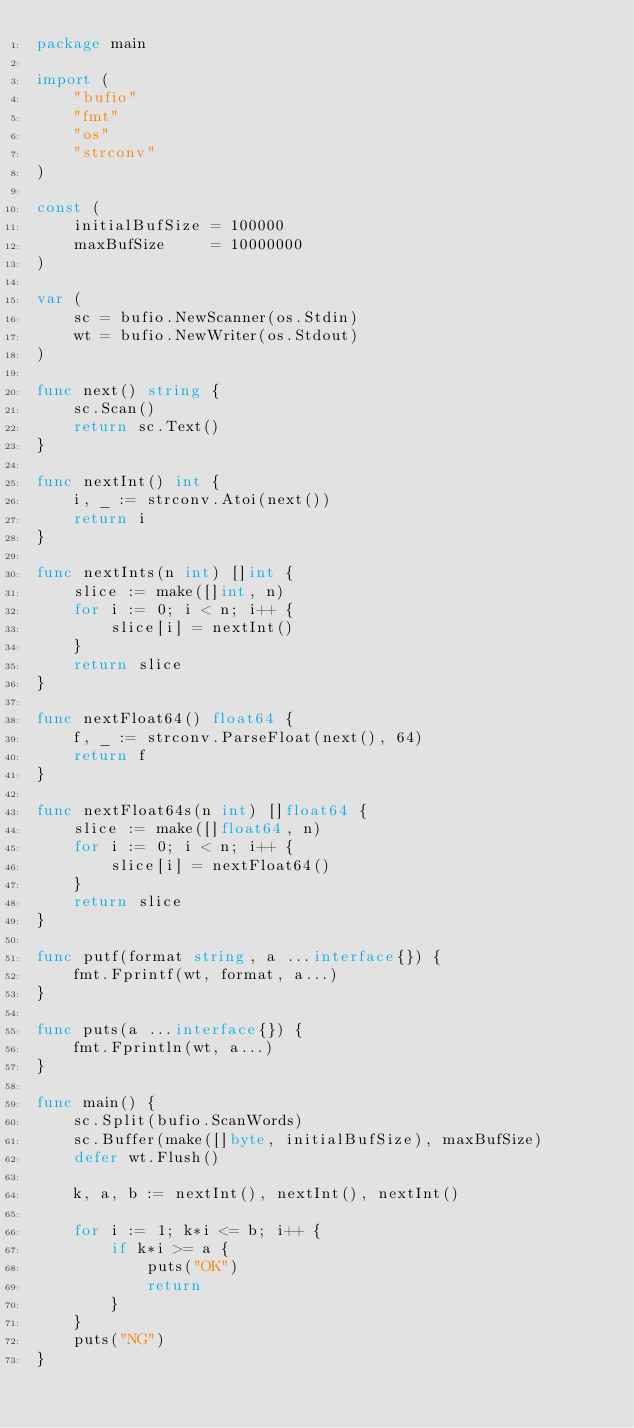<code> <loc_0><loc_0><loc_500><loc_500><_Go_>package main

import (
	"bufio"
	"fmt"
	"os"
	"strconv"
)

const (
	initialBufSize = 100000
	maxBufSize     = 10000000
)

var (
	sc = bufio.NewScanner(os.Stdin)
	wt = bufio.NewWriter(os.Stdout)
)

func next() string {
	sc.Scan()
	return sc.Text()
}

func nextInt() int {
	i, _ := strconv.Atoi(next())
	return i
}

func nextInts(n int) []int {
	slice := make([]int, n)
	for i := 0; i < n; i++ {
		slice[i] = nextInt()
	}
	return slice
}

func nextFloat64() float64 {
	f, _ := strconv.ParseFloat(next(), 64)
	return f
}

func nextFloat64s(n int) []float64 {
	slice := make([]float64, n)
	for i := 0; i < n; i++ {
		slice[i] = nextFloat64()
	}
	return slice
}

func putf(format string, a ...interface{}) {
	fmt.Fprintf(wt, format, a...)
}

func puts(a ...interface{}) {
	fmt.Fprintln(wt, a...)
}

func main() {
	sc.Split(bufio.ScanWords)
	sc.Buffer(make([]byte, initialBufSize), maxBufSize)
	defer wt.Flush()

	k, a, b := nextInt(), nextInt(), nextInt()

	for i := 1; k*i <= b; i++ {
		if k*i >= a {
			puts("OK")
			return
		}
	}
	puts("NG")
}
</code> 